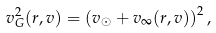Convert formula to latex. <formula><loc_0><loc_0><loc_500><loc_500>v _ { G } ^ { 2 } ( { r } , { v } ) = \left ( { v } _ { \odot } + { v } _ { \infty } ( { r } , { v } ) \right ) ^ { 2 } ,</formula> 